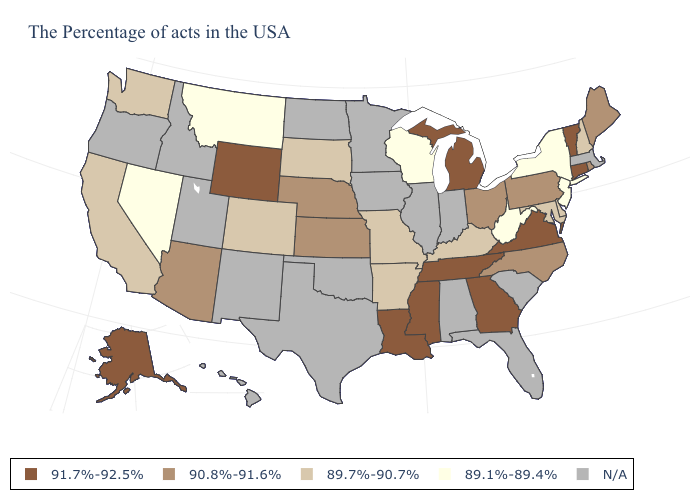Name the states that have a value in the range 89.1%-89.4%?
Short answer required. New York, New Jersey, West Virginia, Wisconsin, Montana, Nevada. Which states hav the highest value in the MidWest?
Be succinct. Michigan. What is the lowest value in the USA?
Be succinct. 89.1%-89.4%. Name the states that have a value in the range 91.7%-92.5%?
Be succinct. Vermont, Connecticut, Virginia, Georgia, Michigan, Tennessee, Mississippi, Louisiana, Wyoming, Alaska. What is the lowest value in the West?
Quick response, please. 89.1%-89.4%. What is the highest value in the South ?
Short answer required. 91.7%-92.5%. Name the states that have a value in the range 89.7%-90.7%?
Keep it brief. New Hampshire, Delaware, Maryland, Kentucky, Missouri, Arkansas, South Dakota, Colorado, California, Washington. Name the states that have a value in the range 89.1%-89.4%?
Short answer required. New York, New Jersey, West Virginia, Wisconsin, Montana, Nevada. Name the states that have a value in the range 91.7%-92.5%?
Answer briefly. Vermont, Connecticut, Virginia, Georgia, Michigan, Tennessee, Mississippi, Louisiana, Wyoming, Alaska. Is the legend a continuous bar?
Quick response, please. No. Is the legend a continuous bar?
Quick response, please. No. What is the value of Illinois?
Short answer required. N/A. Among the states that border Nevada , which have the highest value?
Answer briefly. Arizona. What is the value of Vermont?
Short answer required. 91.7%-92.5%. 